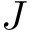Convert formula to latex. <formula><loc_0><loc_0><loc_500><loc_500>J</formula> 